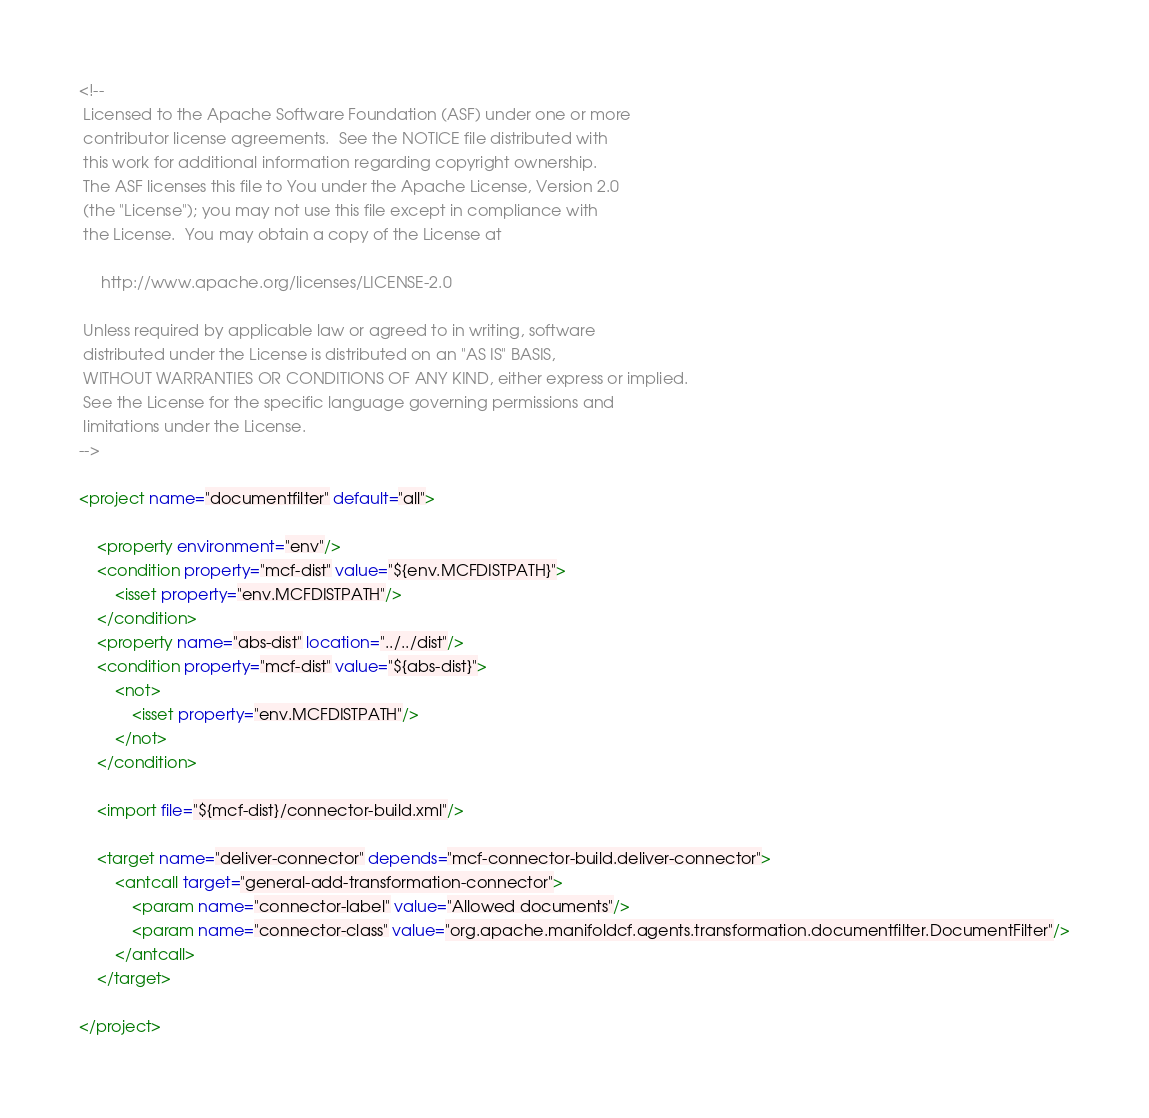Convert code to text. <code><loc_0><loc_0><loc_500><loc_500><_XML_><!--
 Licensed to the Apache Software Foundation (ASF) under one or more
 contributor license agreements.  See the NOTICE file distributed with
 this work for additional information regarding copyright ownership.
 The ASF licenses this file to You under the Apache License, Version 2.0
 (the "License"); you may not use this file except in compliance with
 the License.  You may obtain a copy of the License at

     http://www.apache.org/licenses/LICENSE-2.0

 Unless required by applicable law or agreed to in writing, software
 distributed under the License is distributed on an "AS IS" BASIS,
 WITHOUT WARRANTIES OR CONDITIONS OF ANY KIND, either express or implied.
 See the License for the specific language governing permissions and
 limitations under the License.
-->

<project name="documentfilter" default="all">

    <property environment="env"/>
    <condition property="mcf-dist" value="${env.MCFDISTPATH}">
        <isset property="env.MCFDISTPATH"/>
    </condition>
    <property name="abs-dist" location="../../dist"/>
    <condition property="mcf-dist" value="${abs-dist}">
        <not>
            <isset property="env.MCFDISTPATH"/>
        </not>
    </condition>

    <import file="${mcf-dist}/connector-build.xml"/>

    <target name="deliver-connector" depends="mcf-connector-build.deliver-connector">
        <antcall target="general-add-transformation-connector">
            <param name="connector-label" value="Allowed documents"/>
            <param name="connector-class" value="org.apache.manifoldcf.agents.transformation.documentfilter.DocumentFilter"/>
        </antcall>
    </target>

</project>
</code> 